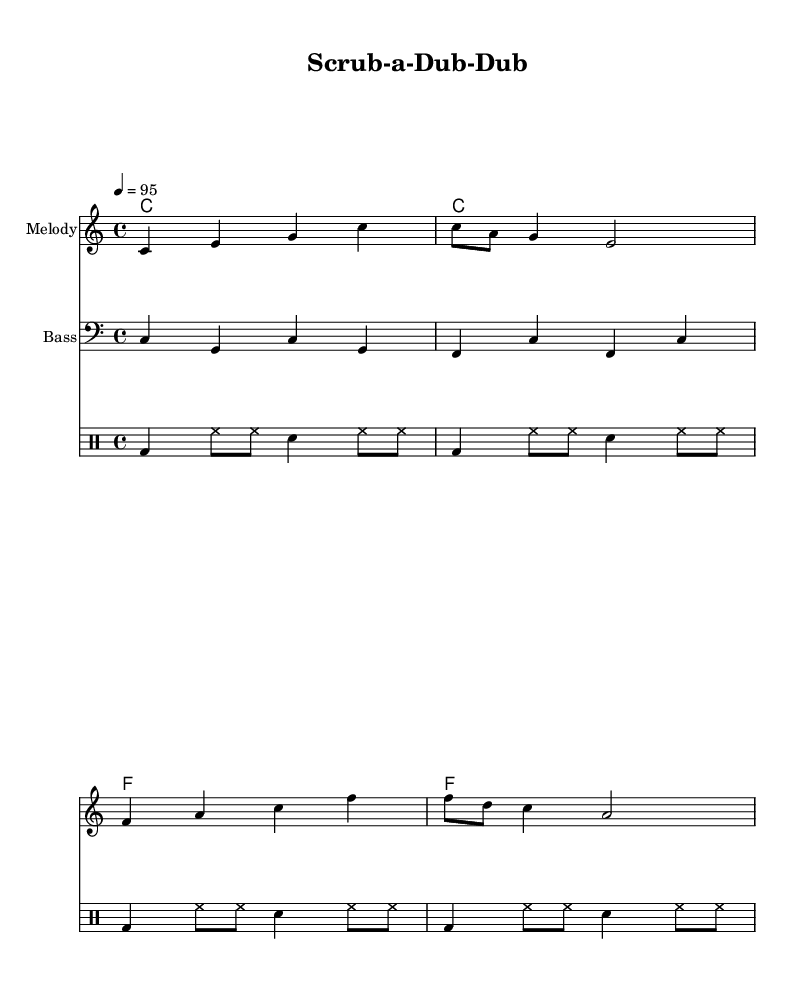What is the key signature of this music? The key signature is determined by looking at the first few measures where it identifies the scale used. Here, it shows no sharps or flats, indicating it is in C major.
Answer: C major What is the time signature of this piece? The time signature is found at the beginning of the music, represented as 4/4, which counts four beats in a measure and indicates a common time signature.
Answer: 4/4 What is the tempo marking for this piece? The tempo marking, indicated by "4 = 95," shows that there are 95 quarter note beats per minute, giving a feel for the speed of the music.
Answer: 95 How many measures are in the melody? Counting each group of bars, the melody section has a total of four measures as each measure is separated, leading to a straightforward count of four distinct units.
Answer: 4 What type of music is this? Upon reviewing the title and lyrical content, it becomes clear that the genre is specific because it focuses on teaching kids through a rhythmic and lyrical format typical of hip-hop or rap.
Answer: Rap What instruments are indicated in the score? The score shows two staves with labeled instrumentation: one for the melody and another for bass, alongside a drum staff for percussion, indicating three distinct instrumental parts.
Answer: Melody, Bass, Drums 